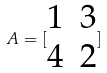<formula> <loc_0><loc_0><loc_500><loc_500>A = [ \begin{matrix} 1 & 3 \\ 4 & 2 \end{matrix} ]</formula> 